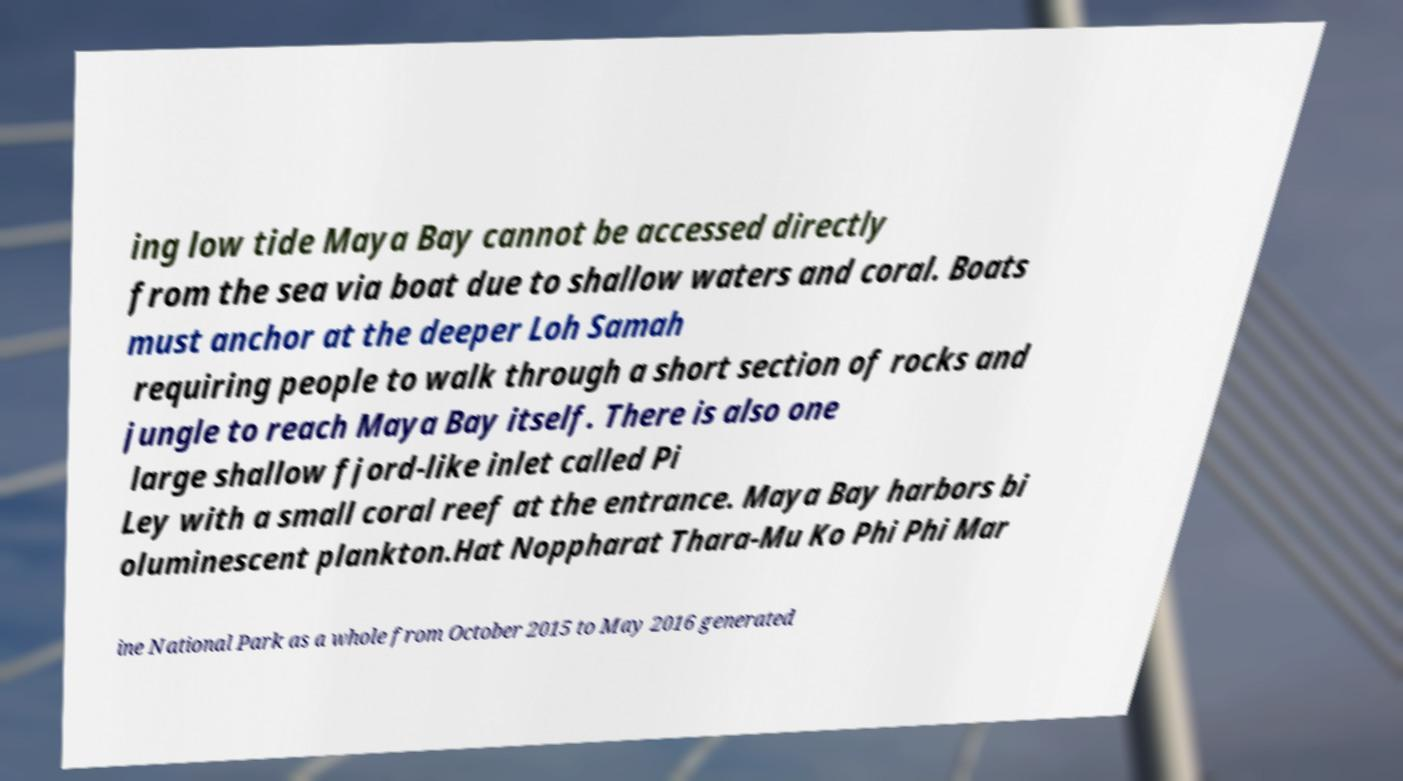Please identify and transcribe the text found in this image. ing low tide Maya Bay cannot be accessed directly from the sea via boat due to shallow waters and coral. Boats must anchor at the deeper Loh Samah requiring people to walk through a short section of rocks and jungle to reach Maya Bay itself. There is also one large shallow fjord-like inlet called Pi Ley with a small coral reef at the entrance. Maya Bay harbors bi oluminescent plankton.Hat Noppharat Thara-Mu Ko Phi Phi Mar ine National Park as a whole from October 2015 to May 2016 generated 